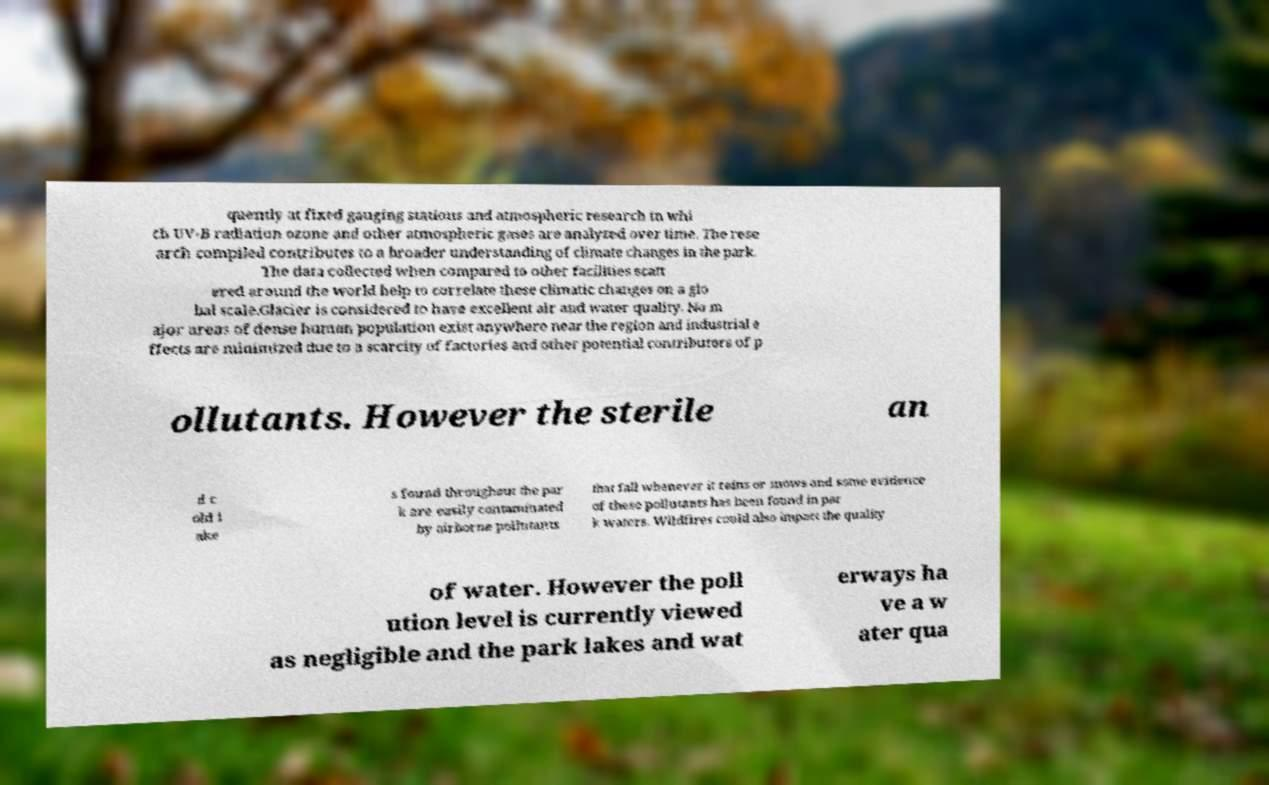I need the written content from this picture converted into text. Can you do that? quently at fixed gauging stations and atmospheric research in whi ch UV-B radiation ozone and other atmospheric gases are analyzed over time. The rese arch compiled contributes to a broader understanding of climate changes in the park. The data collected when compared to other facilities scatt ered around the world help to correlate these climatic changes on a glo bal scale.Glacier is considered to have excellent air and water quality. No m ajor areas of dense human population exist anywhere near the region and industrial e ffects are minimized due to a scarcity of factories and other potential contributors of p ollutants. However the sterile an d c old l ake s found throughout the par k are easily contaminated by airborne pollutants that fall whenever it rains or snows and some evidence of these pollutants has been found in par k waters. Wildfires could also impact the quality of water. However the poll ution level is currently viewed as negligible and the park lakes and wat erways ha ve a w ater qua 